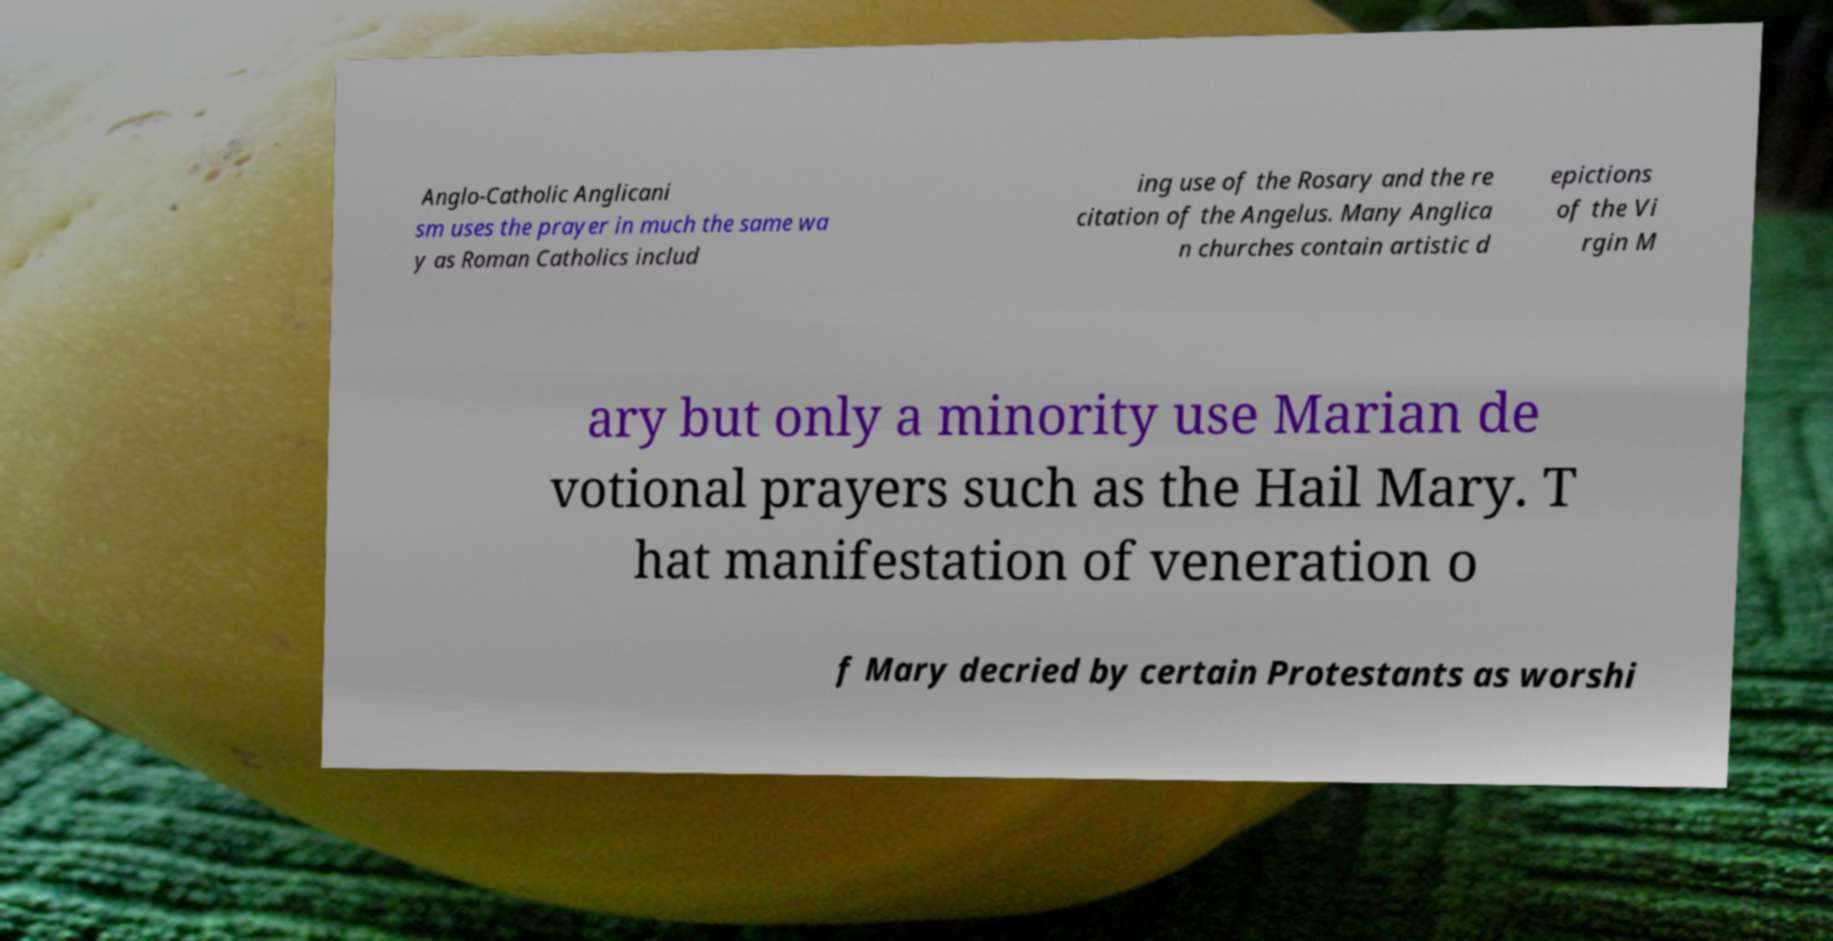Could you extract and type out the text from this image? Anglo-Catholic Anglicani sm uses the prayer in much the same wa y as Roman Catholics includ ing use of the Rosary and the re citation of the Angelus. Many Anglica n churches contain artistic d epictions of the Vi rgin M ary but only a minority use Marian de votional prayers such as the Hail Mary. T hat manifestation of veneration o f Mary decried by certain Protestants as worshi 